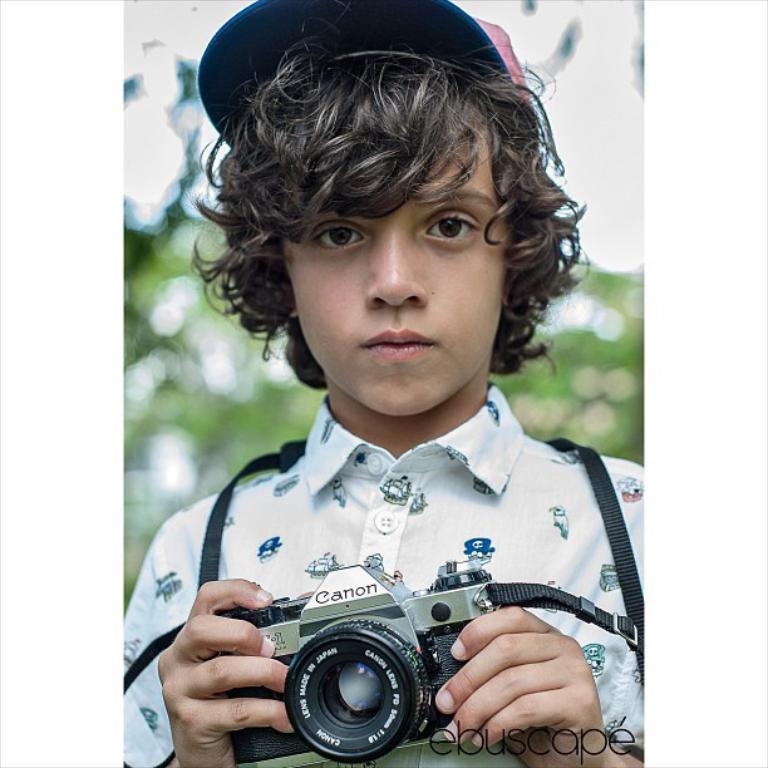Who is the main subject in the picture? There is a boy in the picture. What is the boy wearing on his head? The boy is wearing a cap. What is the boy wearing on his upper body? The boy is wearing a shirt. What object is the boy holding in the picture? The boy is holding a camera. What type of rail can be seen in the background of the image? There is no rail present in the image; it only features a boy wearing a shirt and cap, holding a camera. 